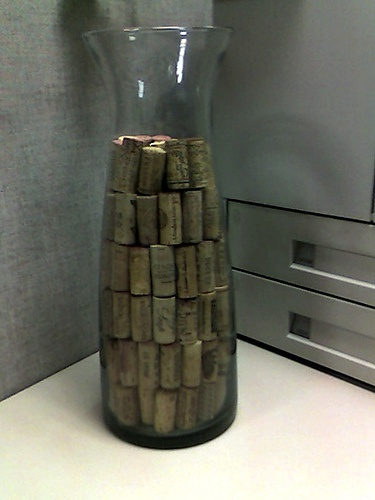Describe the objects in this image and their specific colors. I can see a vase in gray, black, and darkgreen tones in this image. 